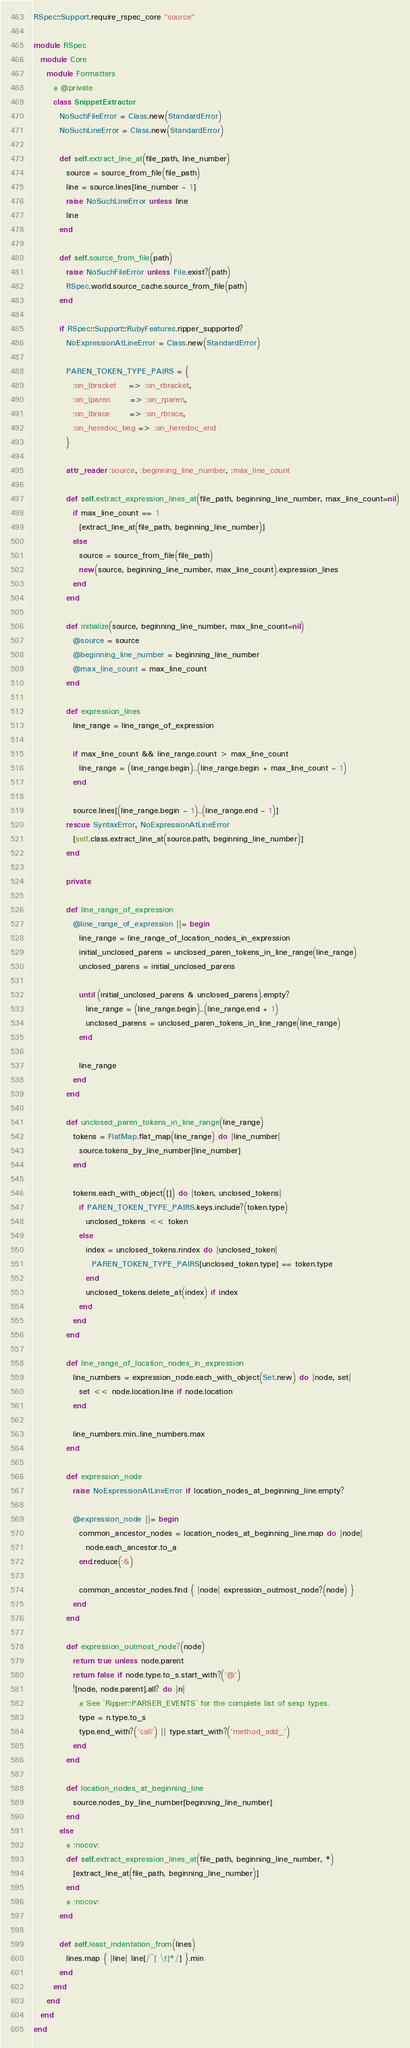<code> <loc_0><loc_0><loc_500><loc_500><_Ruby_>RSpec::Support.require_rspec_core "source"

module RSpec
  module Core
    module Formatters
      # @private
      class SnippetExtractor
        NoSuchFileError = Class.new(StandardError)
        NoSuchLineError = Class.new(StandardError)

        def self.extract_line_at(file_path, line_number)
          source = source_from_file(file_path)
          line = source.lines[line_number - 1]
          raise NoSuchLineError unless line
          line
        end

        def self.source_from_file(path)
          raise NoSuchFileError unless File.exist?(path)
          RSpec.world.source_cache.source_from_file(path)
        end

        if RSpec::Support::RubyFeatures.ripper_supported?
          NoExpressionAtLineError = Class.new(StandardError)

          PAREN_TOKEN_TYPE_PAIRS = {
            :on_lbracket    => :on_rbracket,
            :on_lparen      => :on_rparen,
            :on_lbrace      => :on_rbrace,
            :on_heredoc_beg => :on_heredoc_end
          }

          attr_reader :source, :beginning_line_number, :max_line_count

          def self.extract_expression_lines_at(file_path, beginning_line_number, max_line_count=nil)
            if max_line_count == 1
              [extract_line_at(file_path, beginning_line_number)]
            else
              source = source_from_file(file_path)
              new(source, beginning_line_number, max_line_count).expression_lines
            end
          end

          def initialize(source, beginning_line_number, max_line_count=nil)
            @source = source
            @beginning_line_number = beginning_line_number
            @max_line_count = max_line_count
          end

          def expression_lines
            line_range = line_range_of_expression

            if max_line_count && line_range.count > max_line_count
              line_range = (line_range.begin)..(line_range.begin + max_line_count - 1)
            end

            source.lines[(line_range.begin - 1)..(line_range.end - 1)]
          rescue SyntaxError, NoExpressionAtLineError
            [self.class.extract_line_at(source.path, beginning_line_number)]
          end

          private

          def line_range_of_expression
            @line_range_of_expression ||= begin
              line_range = line_range_of_location_nodes_in_expression
              initial_unclosed_parens = unclosed_paren_tokens_in_line_range(line_range)
              unclosed_parens = initial_unclosed_parens

              until (initial_unclosed_parens & unclosed_parens).empty?
                line_range = (line_range.begin)..(line_range.end + 1)
                unclosed_parens = unclosed_paren_tokens_in_line_range(line_range)
              end

              line_range
            end
          end

          def unclosed_paren_tokens_in_line_range(line_range)
            tokens = FlatMap.flat_map(line_range) do |line_number|
              source.tokens_by_line_number[line_number]
            end

            tokens.each_with_object([]) do |token, unclosed_tokens|
              if PAREN_TOKEN_TYPE_PAIRS.keys.include?(token.type)
                unclosed_tokens << token
              else
                index = unclosed_tokens.rindex do |unclosed_token|
                  PAREN_TOKEN_TYPE_PAIRS[unclosed_token.type] == token.type
                end
                unclosed_tokens.delete_at(index) if index
              end
            end
          end

          def line_range_of_location_nodes_in_expression
            line_numbers = expression_node.each_with_object(Set.new) do |node, set|
              set << node.location.line if node.location
            end

            line_numbers.min..line_numbers.max
          end

          def expression_node
            raise NoExpressionAtLineError if location_nodes_at_beginning_line.empty?

            @expression_node ||= begin
              common_ancestor_nodes = location_nodes_at_beginning_line.map do |node|
                node.each_ancestor.to_a
              end.reduce(:&)

              common_ancestor_nodes.find { |node| expression_outmost_node?(node) }
            end
          end

          def expression_outmost_node?(node)
            return true unless node.parent
            return false if node.type.to_s.start_with?('@')
            ![node, node.parent].all? do |n|
              # See `Ripper::PARSER_EVENTS` for the complete list of sexp types.
              type = n.type.to_s
              type.end_with?('call') || type.start_with?('method_add_')
            end
          end

          def location_nodes_at_beginning_line
            source.nodes_by_line_number[beginning_line_number]
          end
        else
          # :nocov:
          def self.extract_expression_lines_at(file_path, beginning_line_number, *)
            [extract_line_at(file_path, beginning_line_number)]
          end
          # :nocov:
        end

        def self.least_indentation_from(lines)
          lines.map { |line| line[/^[ \t]*/] }.min
        end
      end
    end
  end
end
</code> 